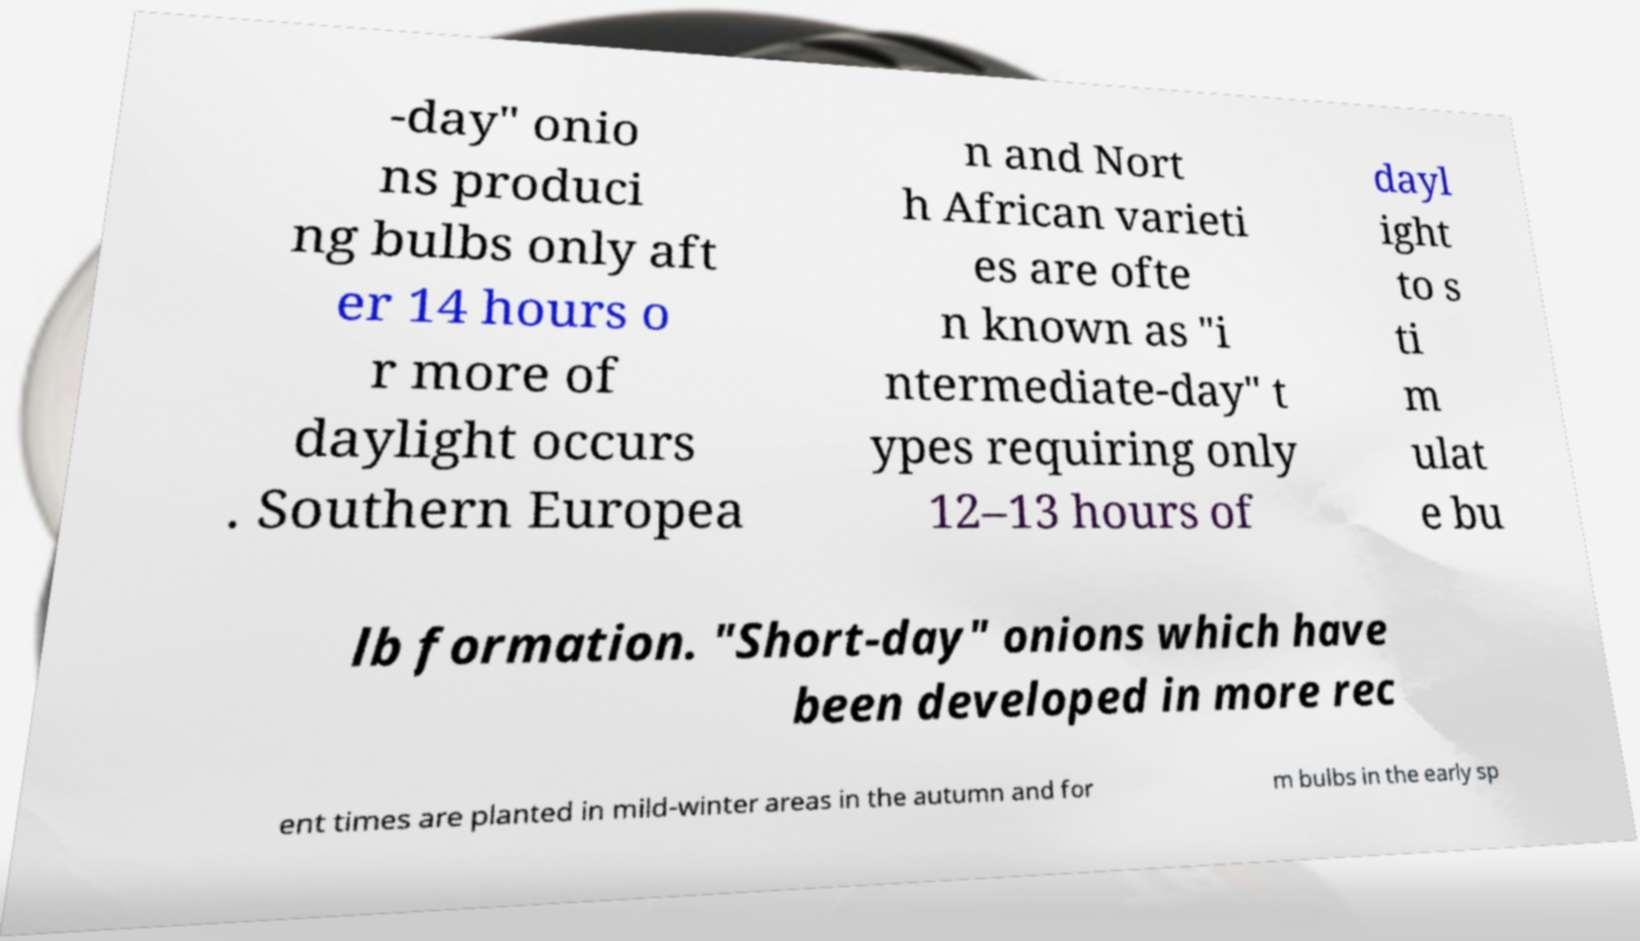For documentation purposes, I need the text within this image transcribed. Could you provide that? -day" onio ns produci ng bulbs only aft er 14 hours o r more of daylight occurs . Southern Europea n and Nort h African varieti es are ofte n known as "i ntermediate-day" t ypes requiring only 12–13 hours of dayl ight to s ti m ulat e bu lb formation. "Short-day" onions which have been developed in more rec ent times are planted in mild-winter areas in the autumn and for m bulbs in the early sp 